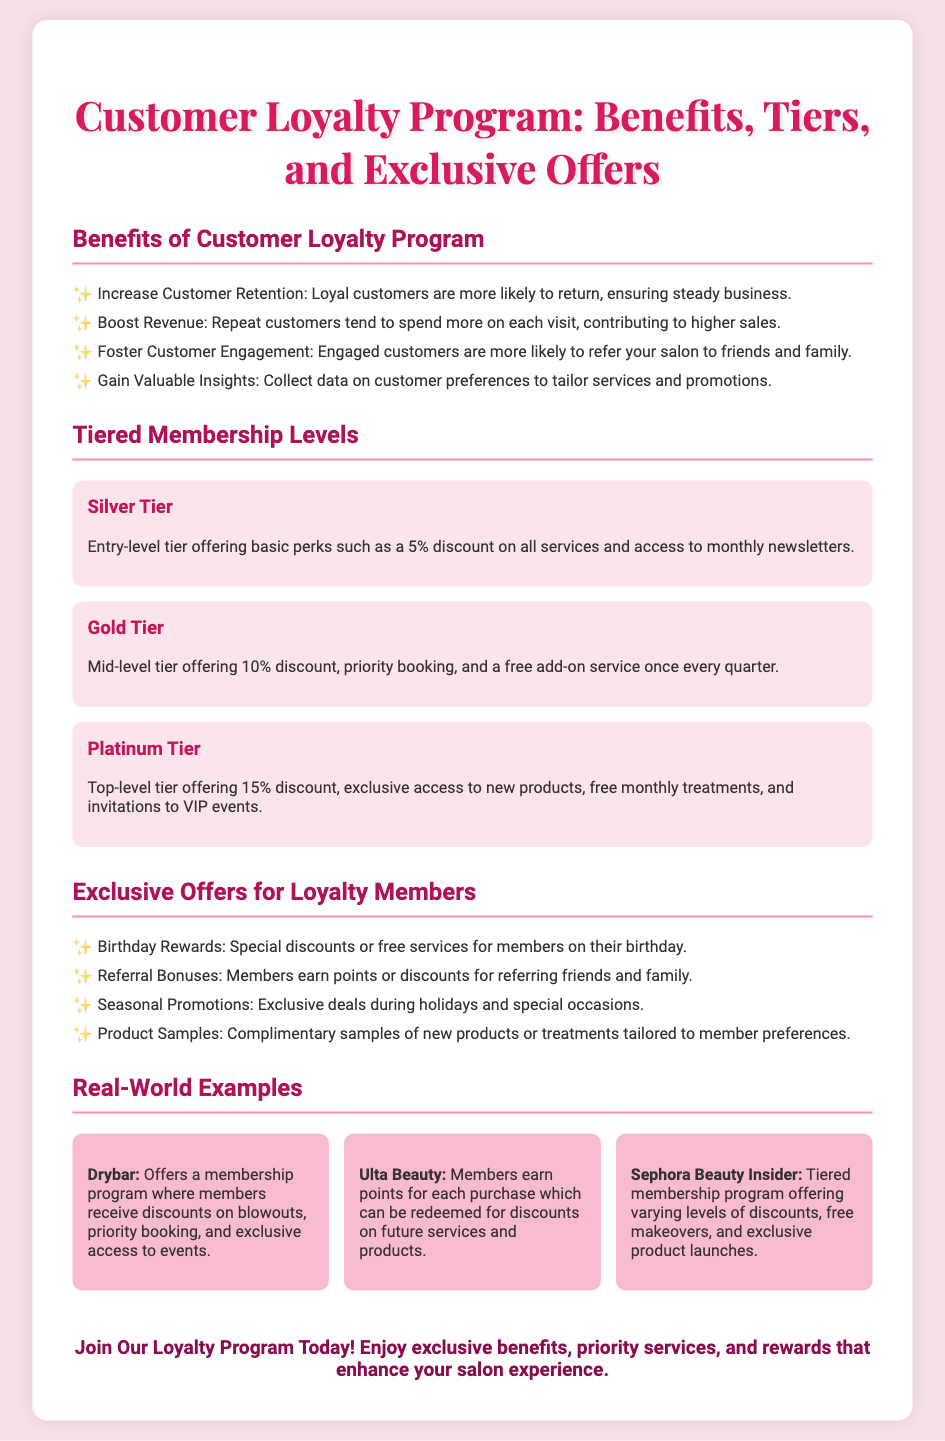what is the discount percentage for the Gold Tier? The Gold Tier offers a 10% discount on services.
Answer: 10% what is one benefit of the Customer Loyalty Program? The program increases customer retention, ensuring steady business.
Answer: Increase Customer Retention how many membership tiers are there in the program? The document lists three membership tiers: Silver, Gold, and Platinum.
Answer: Three what special reward do members receive on their birthday? Members receive special discounts or free services on their birthday.
Answer: Special discounts or free services which company offers a membership program with discounts on blowouts? Drybar is mentioned as offering a membership program with such benefits.
Answer: Drybar what is the main advantage of the Platinum Tier? The Platinum Tier includes exclusive access to new products and free monthly treatments.
Answer: Exclusive access to new products what do members earn for referring friends and family? Members earn points or discounts for referrals.
Answer: Points or discounts what is the footer message encouraging customers to do? The footer encourages customers to join the loyalty program for exclusive benefits.
Answer: Join Our Loyalty Program Today! 